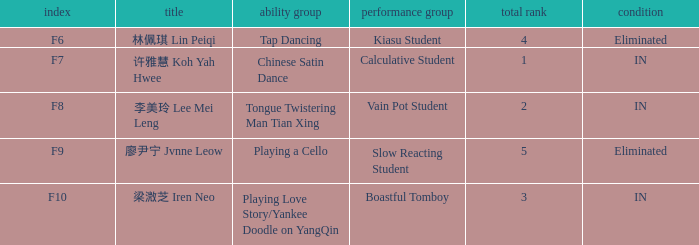What's the acting segment of 林佩琪 lin peiqi's events that are eliminated? Kiasu Student. 